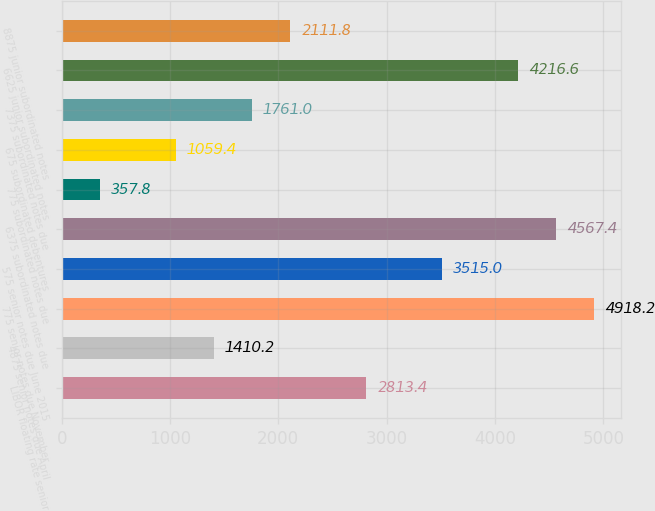Convert chart. <chart><loc_0><loc_0><loc_500><loc_500><bar_chart><fcel>LIBOR floating rate senior<fcel>4875 senior notes due April<fcel>775 senior notes due November<fcel>575 senior notes due June 2015<fcel>6375 subordinated notes due<fcel>775 subordinated notes due<fcel>675 subordinated debentures<fcel>7375 subordinated notes due<fcel>6625 junior subordinated notes<fcel>8875 junior subordinated notes<nl><fcel>2813.4<fcel>1410.2<fcel>4918.2<fcel>3515<fcel>4567.4<fcel>357.8<fcel>1059.4<fcel>1761<fcel>4216.6<fcel>2111.8<nl></chart> 